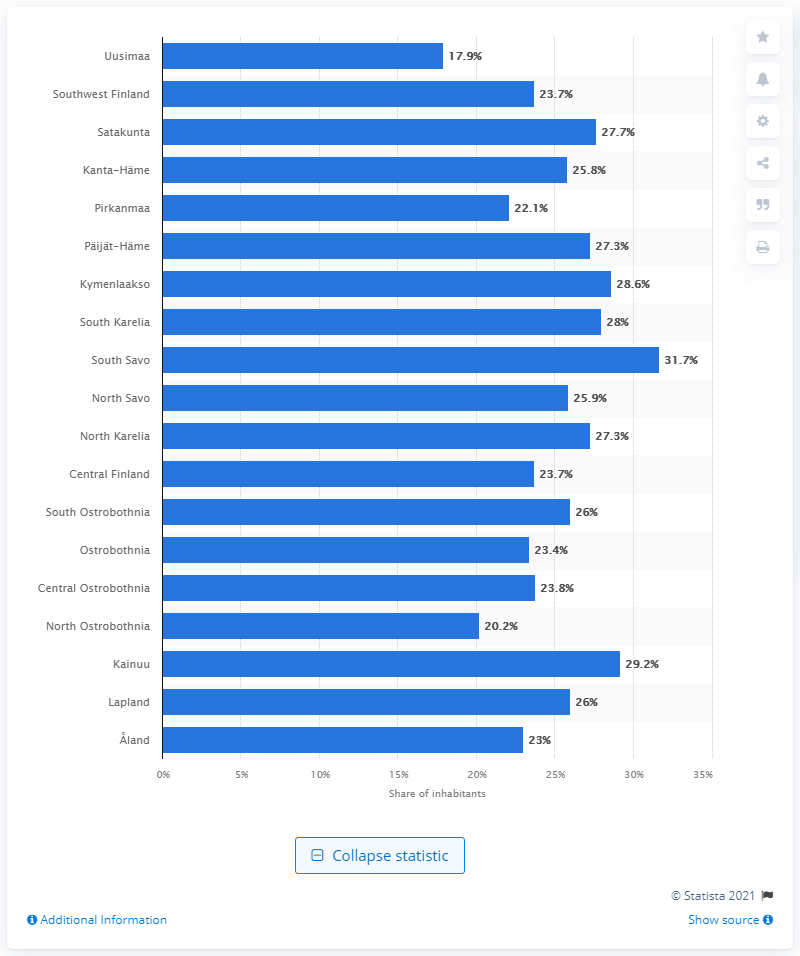Specify some key components in this picture. Uusimaa is the capital region of Finland. 